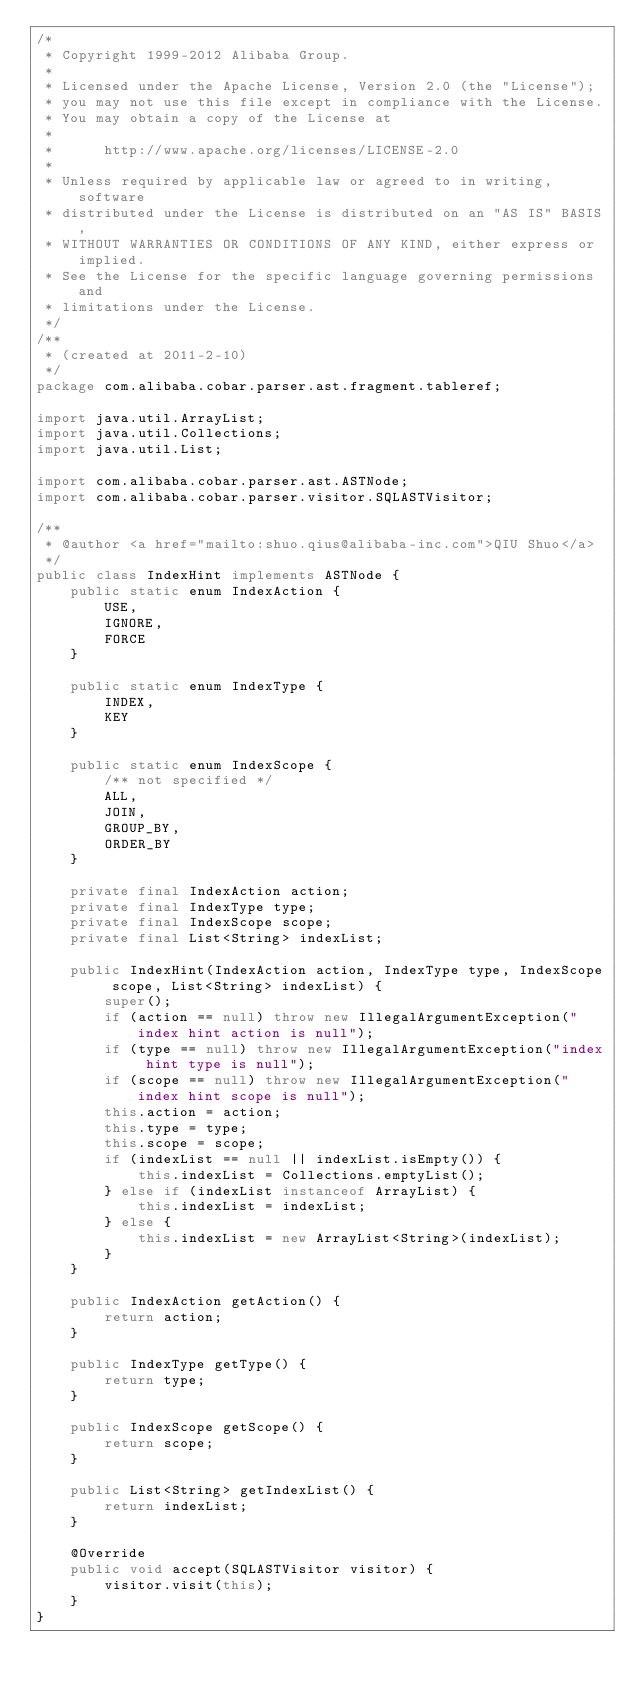<code> <loc_0><loc_0><loc_500><loc_500><_Java_>/*
 * Copyright 1999-2012 Alibaba Group.
 *  
 * Licensed under the Apache License, Version 2.0 (the "License");
 * you may not use this file except in compliance with the License.
 * You may obtain a copy of the License at
 *  
 *      http://www.apache.org/licenses/LICENSE-2.0
 *  
 * Unless required by applicable law or agreed to in writing, software
 * distributed under the License is distributed on an "AS IS" BASIS,
 * WITHOUT WARRANTIES OR CONDITIONS OF ANY KIND, either express or implied.
 * See the License for the specific language governing permissions and
 * limitations under the License.
 */
/**
 * (created at 2011-2-10)
 */
package com.alibaba.cobar.parser.ast.fragment.tableref;

import java.util.ArrayList;
import java.util.Collections;
import java.util.List;

import com.alibaba.cobar.parser.ast.ASTNode;
import com.alibaba.cobar.parser.visitor.SQLASTVisitor;

/**
 * @author <a href="mailto:shuo.qius@alibaba-inc.com">QIU Shuo</a>
 */
public class IndexHint implements ASTNode {
    public static enum IndexAction {
        USE,
        IGNORE,
        FORCE
    }

    public static enum IndexType {
        INDEX,
        KEY
    }

    public static enum IndexScope {
        /** not specified */
        ALL,
        JOIN,
        GROUP_BY,
        ORDER_BY
    }

    private final IndexAction action;
    private final IndexType type;
    private final IndexScope scope;
    private final List<String> indexList;

    public IndexHint(IndexAction action, IndexType type, IndexScope scope, List<String> indexList) {
        super();
        if (action == null) throw new IllegalArgumentException("index hint action is null");
        if (type == null) throw new IllegalArgumentException("index hint type is null");
        if (scope == null) throw new IllegalArgumentException("index hint scope is null");
        this.action = action;
        this.type = type;
        this.scope = scope;
        if (indexList == null || indexList.isEmpty()) {
            this.indexList = Collections.emptyList();
        } else if (indexList instanceof ArrayList) {
            this.indexList = indexList;
        } else {
            this.indexList = new ArrayList<String>(indexList);
        }
    }

    public IndexAction getAction() {
        return action;
    }

    public IndexType getType() {
        return type;
    }

    public IndexScope getScope() {
        return scope;
    }

    public List<String> getIndexList() {
        return indexList;
    }

    @Override
    public void accept(SQLASTVisitor visitor) {
        visitor.visit(this);
    }
}
</code> 